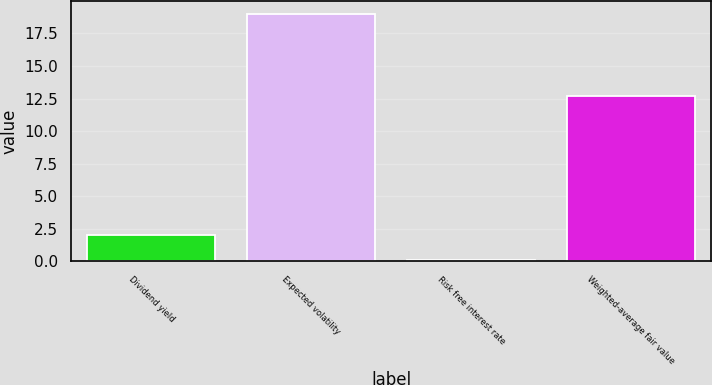Convert chart. <chart><loc_0><loc_0><loc_500><loc_500><bar_chart><fcel>Dividend yield<fcel>Expected volatility<fcel>Risk free interest rate<fcel>Weighted-average fair value<nl><fcel>1.99<fcel>19<fcel>0.1<fcel>12.67<nl></chart> 